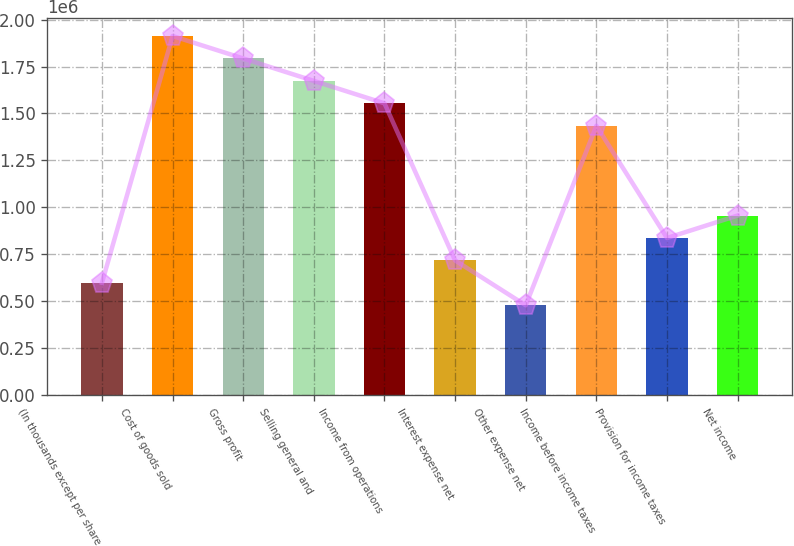Convert chart. <chart><loc_0><loc_0><loc_500><loc_500><bar_chart><fcel>(In thousands except per share<fcel>Cost of goods sold<fcel>Gross profit<fcel>Selling general and<fcel>Income from operations<fcel>Interest expense net<fcel>Other expense net<fcel>Income before income taxes<fcel>Provision for income taxes<fcel>Net income<nl><fcel>597691<fcel>1.91261e+06<fcel>1.79307e+06<fcel>1.67353e+06<fcel>1.554e+06<fcel>717229<fcel>478153<fcel>1.43446e+06<fcel>836767<fcel>956305<nl></chart> 